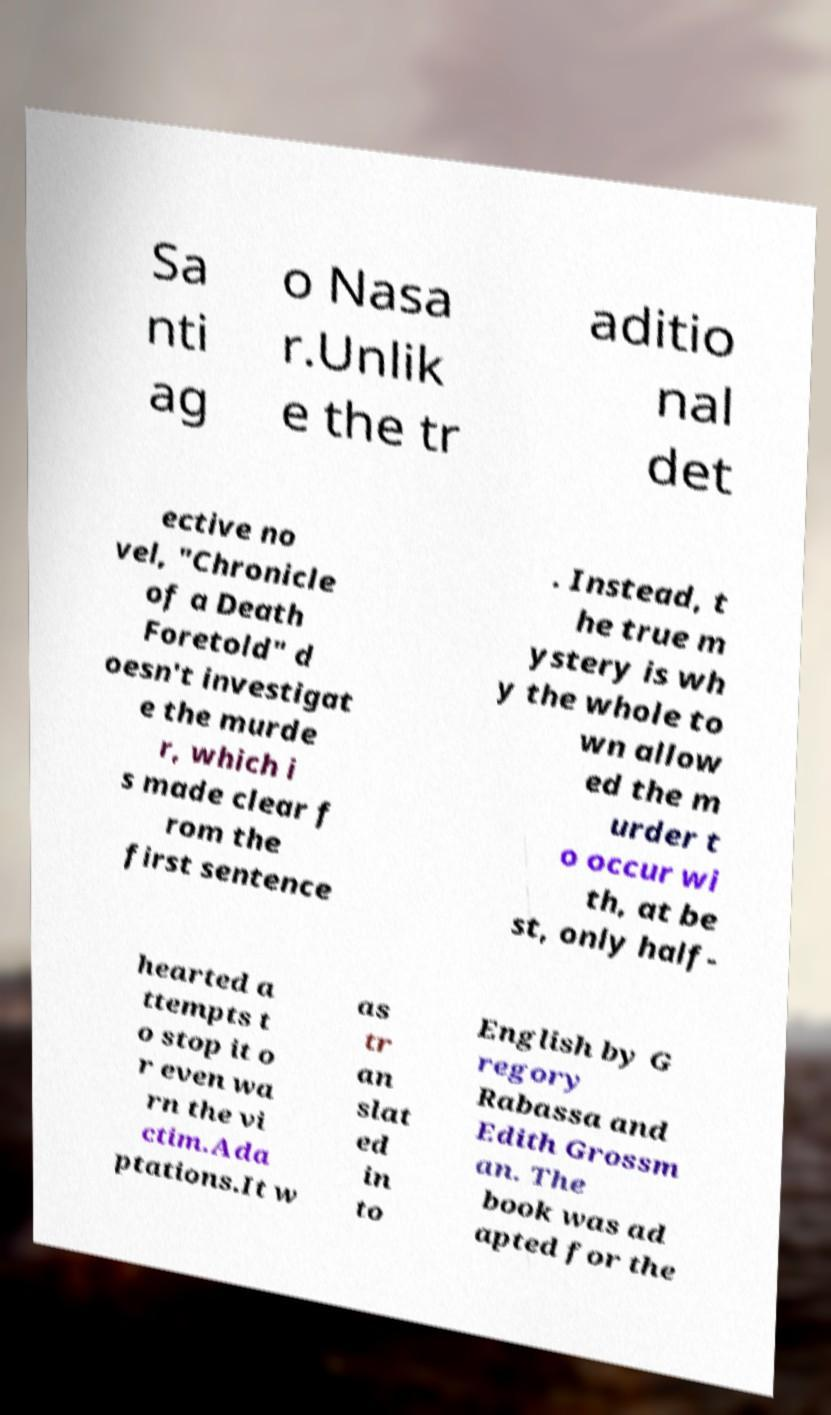There's text embedded in this image that I need extracted. Can you transcribe it verbatim? Sa nti ag o Nasa r.Unlik e the tr aditio nal det ective no vel, "Chronicle of a Death Foretold" d oesn't investigat e the murde r, which i s made clear f rom the first sentence . Instead, t he true m ystery is wh y the whole to wn allow ed the m urder t o occur wi th, at be st, only half- hearted a ttempts t o stop it o r even wa rn the vi ctim.Ada ptations.It w as tr an slat ed in to English by G regory Rabassa and Edith Grossm an. The book was ad apted for the 